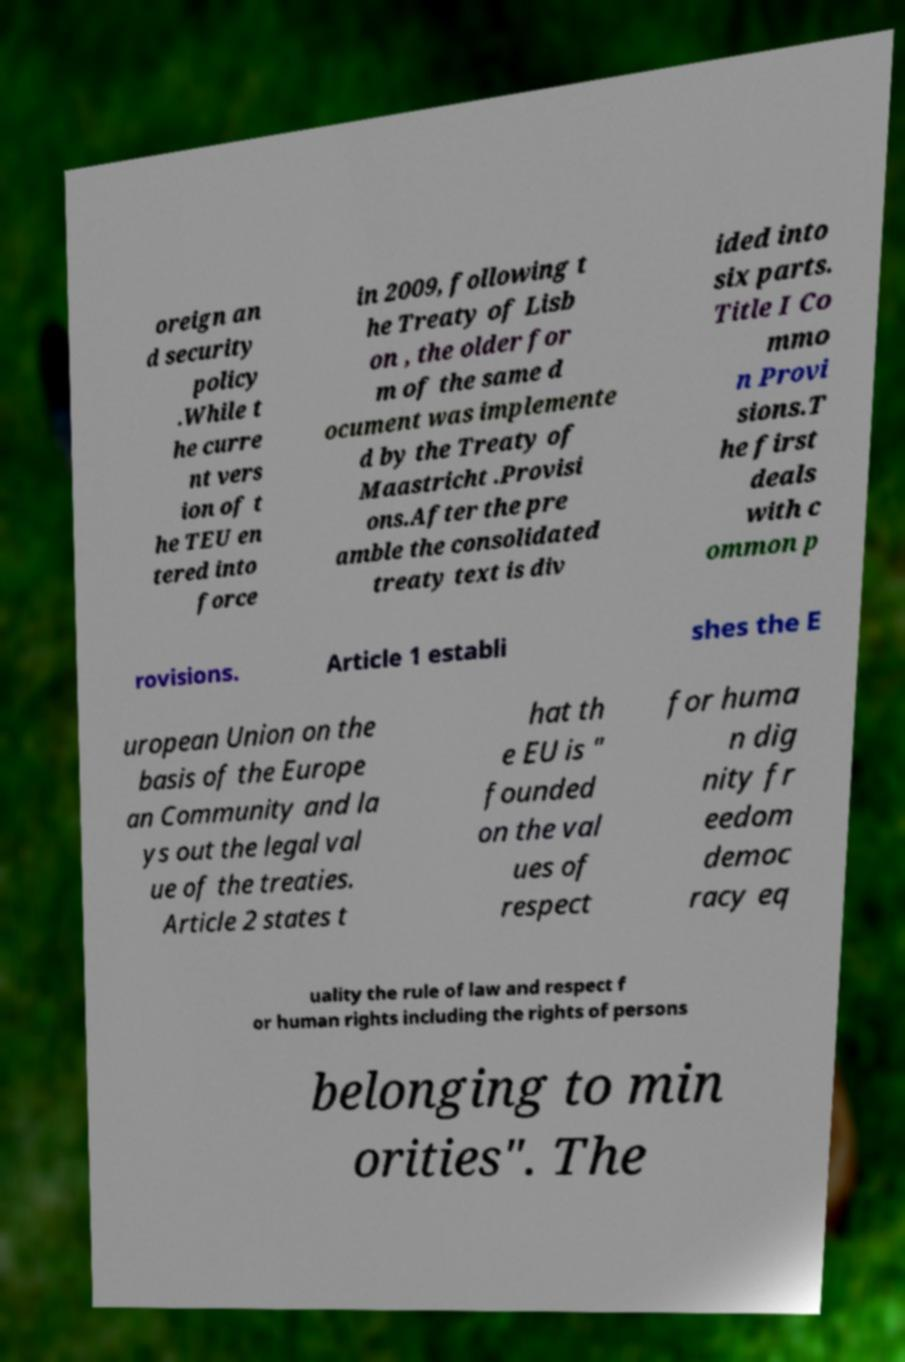Could you assist in decoding the text presented in this image and type it out clearly? oreign an d security policy .While t he curre nt vers ion of t he TEU en tered into force in 2009, following t he Treaty of Lisb on , the older for m of the same d ocument was implemente d by the Treaty of Maastricht .Provisi ons.After the pre amble the consolidated treaty text is div ided into six parts. Title I Co mmo n Provi sions.T he first deals with c ommon p rovisions. Article 1 establi shes the E uropean Union on the basis of the Europe an Community and la ys out the legal val ue of the treaties. Article 2 states t hat th e EU is " founded on the val ues of respect for huma n dig nity fr eedom democ racy eq uality the rule of law and respect f or human rights including the rights of persons belonging to min orities". The 